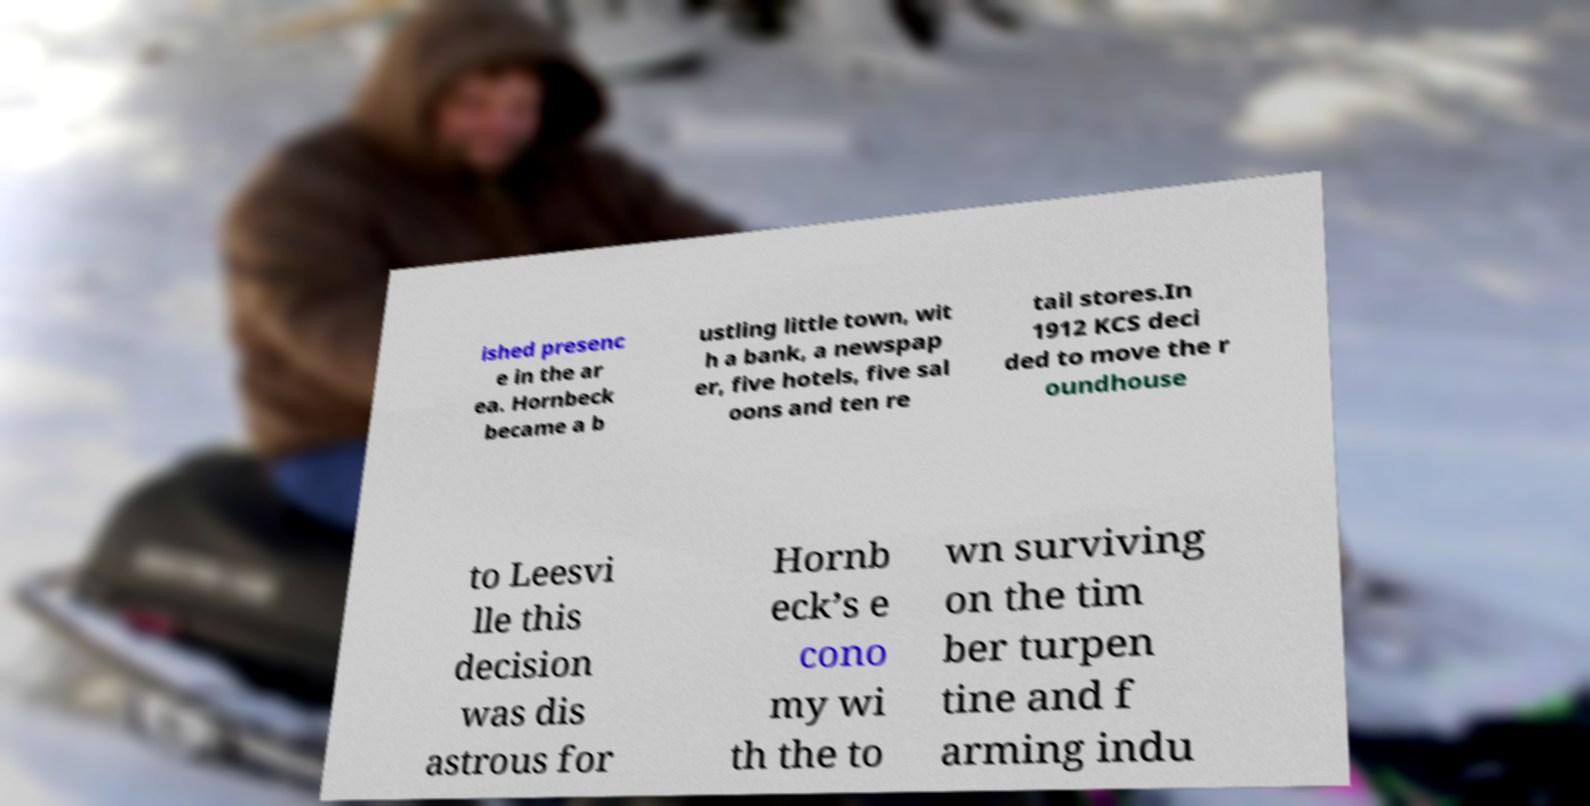Could you extract and type out the text from this image? ished presenc e in the ar ea. Hornbeck became a b ustling little town, wit h a bank, a newspap er, five hotels, five sal oons and ten re tail stores.In 1912 KCS deci ded to move the r oundhouse to Leesvi lle this decision was dis astrous for Hornb eck’s e cono my wi th the to wn surviving on the tim ber turpen tine and f arming indu 